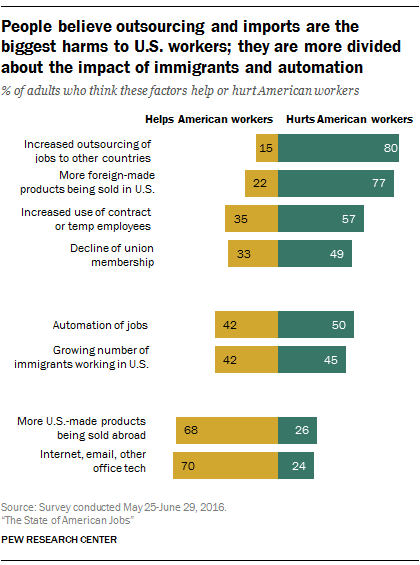Indicate a few pertinent items in this graphic. The result of taking the sum of the two smallest green bars and the smallest yellow bars and then deducting the smaller value from the larger value is 25. 